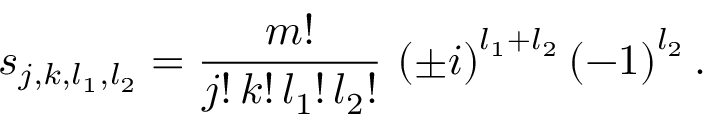Convert formula to latex. <formula><loc_0><loc_0><loc_500><loc_500>s _ { j , k , l _ { 1 } , l _ { 2 } } = \frac { m ! } { j ! \, k ! \, l _ { 1 } ! \, l _ { 2 } ! } \, \left ( \pm i \right ) ^ { l _ { 1 } + l _ { 2 } } \left ( - 1 \right ) ^ { l _ { 2 } } .</formula> 